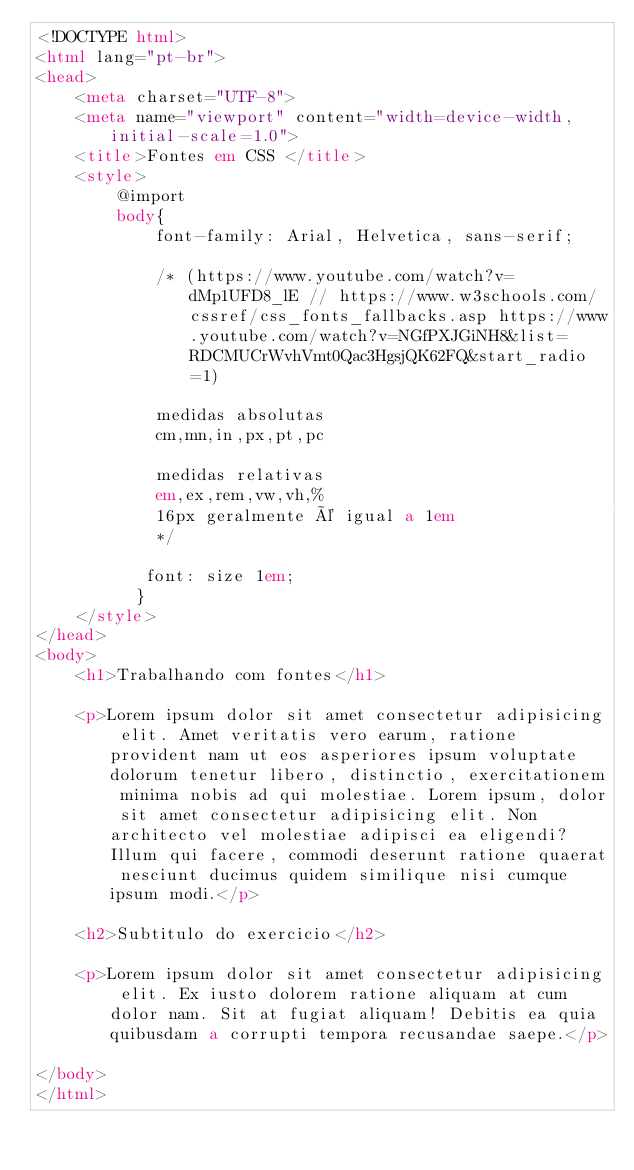Convert code to text. <code><loc_0><loc_0><loc_500><loc_500><_HTML_><!DOCTYPE html>
<html lang="pt-br">
<head>
    <meta charset="UTF-8">
    <meta name="viewport" content="width=device-width, initial-scale=1.0">
    <title>Fontes em CSS </title>
    <style>
        @import
        body{
            font-family: Arial, Helvetica, sans-serif;

            /* (https://www.youtube.com/watch?v=dMp1UFD8_lE // https://www.w3schools.com/cssref/css_fonts_fallbacks.asp https://www.youtube.com/watch?v=NGfPXJGiNH8&list=RDCMUCrWvhVmt0Qac3HgsjQK62FQ&start_radio=1)

            medidas absolutas
            cm,mn,in,px,pt,pc

            medidas relativas
            em,ex,rem,vw,vh,%
            16px geralmente é igual a 1em
            */
            
           font: size 1em; 
          }
    </style>
</head>
<body>
    <h1>Trabalhando com fontes</h1>

    <p>Lorem ipsum dolor sit amet consectetur adipisicing elit. Amet veritatis vero earum, ratione provident nam ut eos asperiores ipsum voluptate dolorum tenetur libero, distinctio, exercitationem minima nobis ad qui molestiae. Lorem ipsum, dolor sit amet consectetur adipisicing elit. Non architecto vel molestiae adipisci ea eligendi? Illum qui facere, commodi deserunt ratione quaerat nesciunt ducimus quidem similique nisi cumque ipsum modi.</p>

    <h2>Subtitulo do exercicio</h2>

    <p>Lorem ipsum dolor sit amet consectetur adipisicing elit. Ex iusto dolorem ratione aliquam at cum dolor nam. Sit at fugiat aliquam! Debitis ea quia quibusdam a corrupti tempora recusandae saepe.</p>
    
</body>
</html></code> 